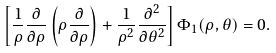Convert formula to latex. <formula><loc_0><loc_0><loc_500><loc_500>\left [ \frac { 1 } \rho \frac { \partial } { \partial \rho } \left ( \rho \frac { \partial } { \partial \rho } \right ) + \frac { 1 } { \rho ^ { 2 } } \frac { \partial ^ { 2 } } { \partial \theta ^ { 2 } } \right ] \Phi _ { 1 } ( \rho , \theta ) = 0 .</formula> 